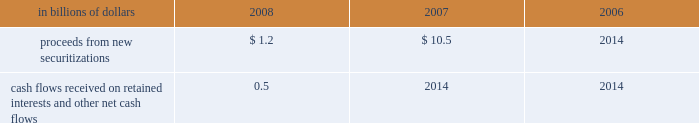Application of specific accounting literature .
For the nonconsolidated proprietary tob trusts and qspe tob trusts , the company recognizes only its residual investment on its balance sheet at fair value and the third-party financing raised by the trusts is off-balance sheet .
The table summarizes selected cash flow information related to municipal bond securitizations for the years 2008 , 2007 and 2006 : in billions of dollars 2008 2007 2006 .
Cash flows received on retained interests and other net cash flows 0.5 2014 2014 municipal investments municipal investment transactions represent partnerships that finance the construction and rehabilitation of low-income affordable rental housing .
The company generally invests in these partnerships as a limited partner and earns a return primarily through the receipt of tax credits earned from the affordable housing investments made by the partnership .
Client intermediation client intermediation transactions represent a range of transactions designed to provide investors with specified returns based on the returns of an underlying security , referenced asset or index .
These transactions include credit-linked notes and equity-linked notes .
In these transactions , the spe typically obtains exposure to the underlying security , referenced asset or index through a derivative instrument , such as a total-return swap or a credit-default swap .
In turn the spe issues notes to investors that pay a return based on the specified underlying security , referenced asset or index .
The spe invests the proceeds in a financial asset or a guaranteed insurance contract ( gic ) that serves as collateral for the derivative contract over the term of the transaction .
The company 2019s involvement in these transactions includes being the counterparty to the spe 2019s derivative instruments and investing in a portion of the notes issued by the spe .
In certain transactions , the investor 2019s maximum risk of loss is limited and the company absorbs risk of loss above a specified level .
The company 2019s maximum risk of loss in these transactions is defined as the amount invested in notes issued by the spe and the notional amount of any risk of loss absorbed by the company through a separate instrument issued by the spe .
The derivative instrument held by the company may generate a receivable from the spe ( for example , where the company purchases credit protection from the spe in connection with the spe 2019s issuance of a credit-linked note ) , which is collateralized by the assets owned by the spe .
These derivative instruments are not considered variable interests under fin 46 ( r ) and any associated receivables are not included in the calculation of maximum exposure to the spe .
Structured investment vehicles structured investment vehicles ( sivs ) are spes that issue junior notes and senior debt ( medium-term notes and short-term commercial paper ) to fund the purchase of high quality assets .
The junior notes are subject to the 201cfirst loss 201d risk of the sivs .
The sivs provide a variable return to the junior note investors based on the net spread between the cost to issue the senior debt and the return realized by the high quality assets .
The company acts as manager for the sivs and , prior to december 13 , 2007 , was not contractually obligated to provide liquidity facilities or guarantees to the sivs .
In response to the ratings review of the outstanding senior debt of the sivs for a possible downgrade announced by two ratings agencies and the continued reduction of liquidity in the siv-related asset-backed commercial paper and medium-term note markets , on december 13 , 2007 , citigroup announced its commitment to provide support facilities that would support the sivs 2019 senior debt ratings .
As a result of this commitment , citigroup became the sivs 2019 primary beneficiary and began consolidating these entities .
On february 12 , 2008 , citigroup finalized the terms of the support facilities , which took the form of a commitment to provide $ 3.5 billion of mezzanine capital to the sivs in the event the market value of their junior notes approaches zero .
The mezzanine capital facility was increased by $ 1 billion to $ 4.5 billion , with the additional commitment funded during the fourth quarter of 2008 .
The facilities rank senior to the junior notes but junior to the commercial paper and medium-term notes .
The facilities were at arm 2019s-length terms .
Interest was paid on the drawn amount of the facilities and a per annum fee was paid on the unused portion .
During the period to november 18 , 2008 , the company wrote down $ 3.3 billion on siv assets .
In order to complete the wind-down of the sivs , the company , in a nearly cashless transaction , purchased the remaining assets of the sivs at fair value , with a trade date of november 18 , 2008 .
The company funded the purchase of the siv assets by assuming the obligation to pay amounts due under the medium-term notes issued by the sivs , as the medium-term notes mature .
The net funding provided by the company to fund the purchase of the siv assets was $ 0.3 billion .
As of december 31 , 2008 , the carrying amount of the purchased siv assets was $ 16.6 billion , of which $ 16.5 billion is classified as htm assets .
Investment funds the company is the investment manager for certain investment funds that invest in various asset classes including private equity , hedge funds , real estate , fixed income and infrastructure .
The company earns a management fee , which is a percentage of capital under management , and may earn performance fees .
In addition , for some of these funds the company has an ownership interest in the investment funds .
The company has also established a number of investment funds as opportunities for qualified employees to invest in private equity investments .
The company acts as investment manager to these funds and may provide employees with financing on both a recourse and non-recourse basis for a portion of the employees 2019 investment commitments. .
What was the difference in billions of proceeds from new securitizations from 2007 to 2008? 
Computations: (1.2 - 10.5)
Answer: -9.3. 